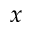Convert formula to latex. <formula><loc_0><loc_0><loc_500><loc_500>x</formula> 